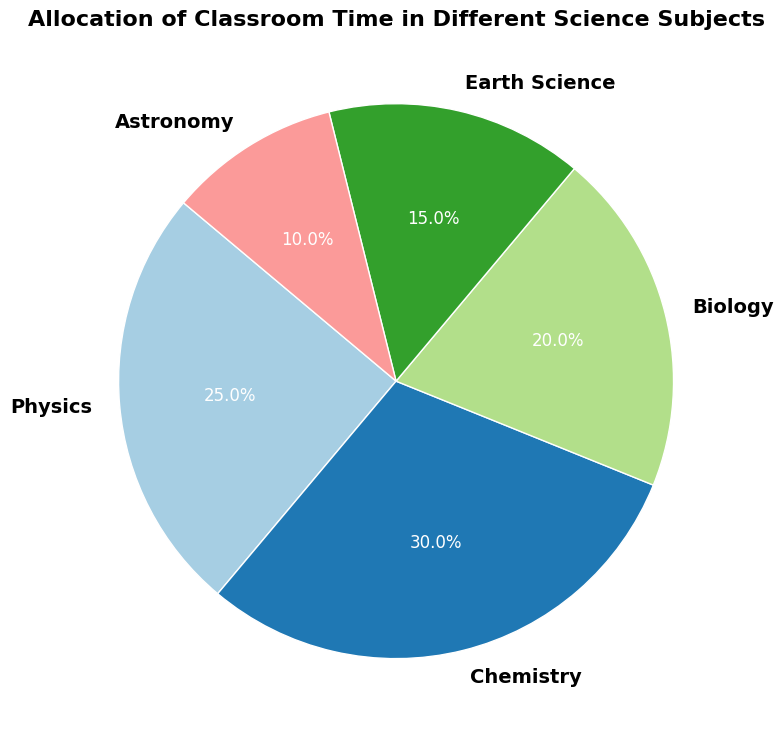What percentage of classroom time is allocated to Biology? By observing the pie chart, we can directly see the label for Biology, which indicates its percentage allocation.
Answer: 20% Which subject receives the most classroom time allocation? From the pie chart, look for the segment with the largest area and its corresponding label.
Answer: Chemistry If we combine the time allocated to Earth Science and Astronomy, what percentage of classroom time do they collectively receive? Identify and sum the percentages allocated to Earth Science and Astronomy: 15% (Earth Science) + 10% (Astronomy).
Answer: 25% How does the time allocation for Physics compare to that for Biology? Look at the percentages for Physics and Biology: Physics is 25%, and Biology is 20%. We can see that Physics has 5% more allocation than Biology.
Answer: Physics has 5% more time allocation than Biology Which subject has the second smallest allocation of classroom time? Excluding the smallest segment, identify the next smallest segment and its corresponding label from the pie chart. The smallest is Astronomy (10%), the second smallest is Earth Science (15%).
Answer: Earth Science What is the combined percentage of time allocation for Physics, Chemistry, and Biology? Sum the percentages for these three subjects: 25% (Physics) + 30% (Chemistry) + 20% (Biology).
Answer: 75% What proportion of the total time is allocated to Earth Science relative to Chemistry? From the chart, take the percentages for Earth Science (15%) and Chemistry (30%). Then, divide the Earth Science percentage by the Chemistry percentage: 15% / 30% = 0.5.
Answer: 0.5 Which subject represented on the pie chart uses blue color? Observe the segments and their colors in the pie chart. Identify the segment with blue color and its corresponding label.
Answer: This information cannot be determined exactly as colors are not clearly specified here What's the percentage difference between the subject with the highest allocation and the lowest allocation? Identify the highest allocation (Chemistry, 30%) and the lowest allocation (Astronomy, 10%). Calculate the difference: 30% - 10%.
Answer: 20% How is classroom time allocated between Physics and Chemistry combined compared to the remaining subjects? Sum the percentages for Physics (25%) and Chemistry (30%) to get their combined allocation (25% + 30% = 55%). For the remaining subjects (Biology, Earth Science, Astronomy): 20% + 15% + 10% = 45%.
Answer: Physics and Chemistry combined have 10% more allocation than the remaining subjects 